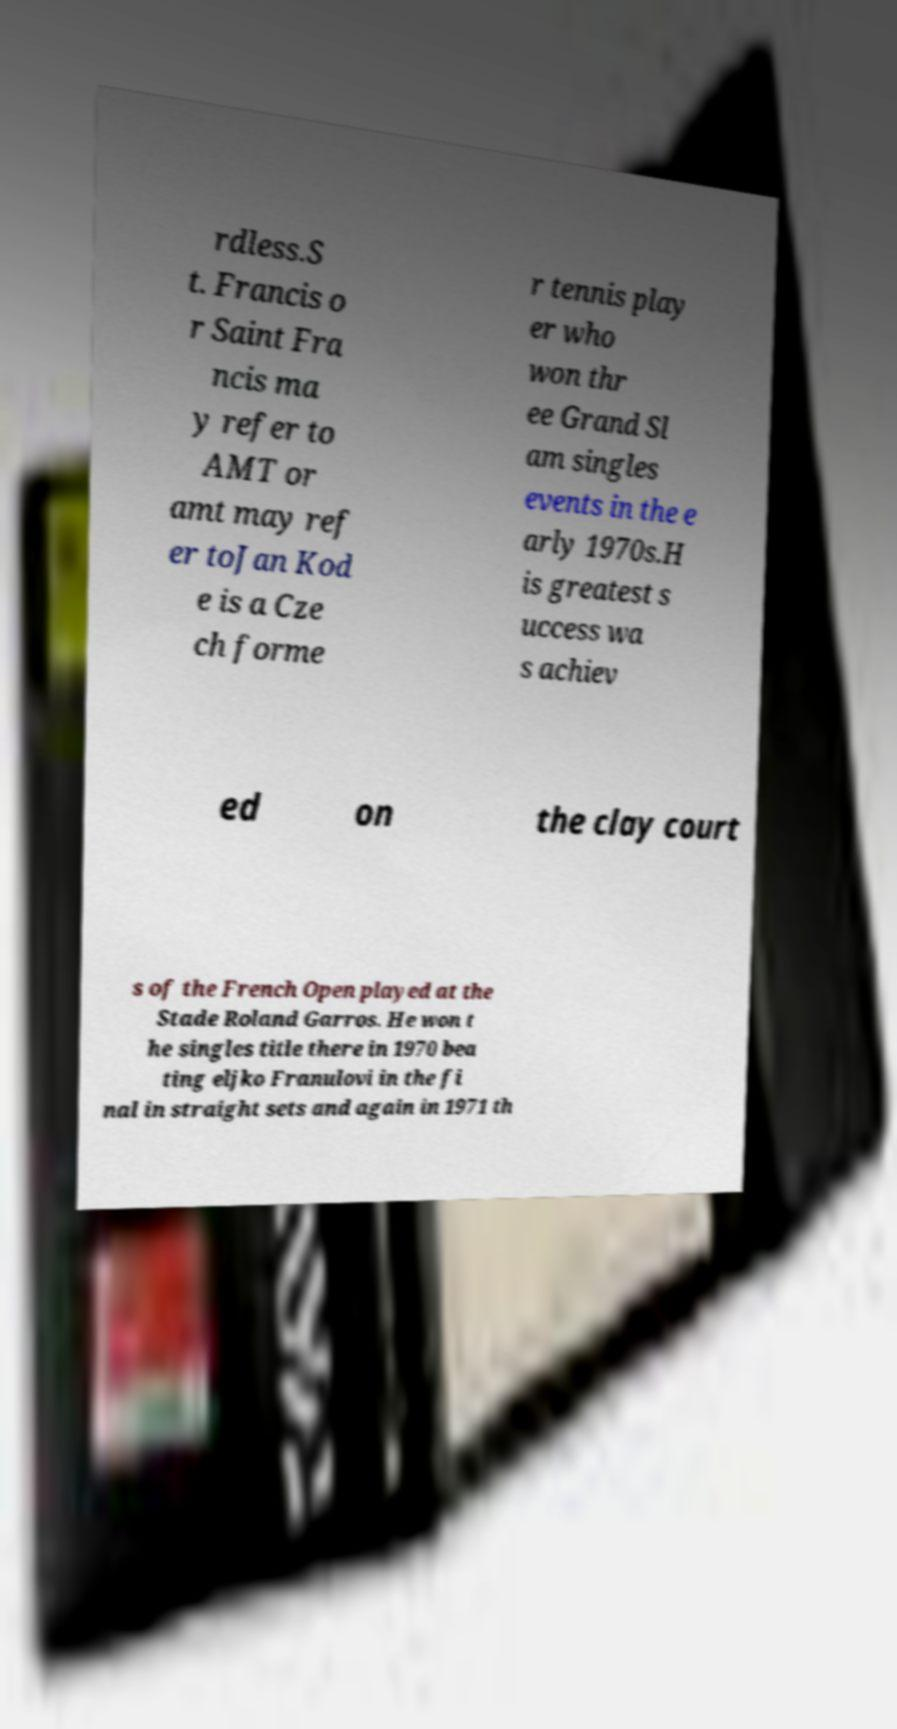For documentation purposes, I need the text within this image transcribed. Could you provide that? rdless.S t. Francis o r Saint Fra ncis ma y refer to AMT or amt may ref er toJan Kod e is a Cze ch forme r tennis play er who won thr ee Grand Sl am singles events in the e arly 1970s.H is greatest s uccess wa s achiev ed on the clay court s of the French Open played at the Stade Roland Garros. He won t he singles title there in 1970 bea ting eljko Franulovi in the fi nal in straight sets and again in 1971 th 